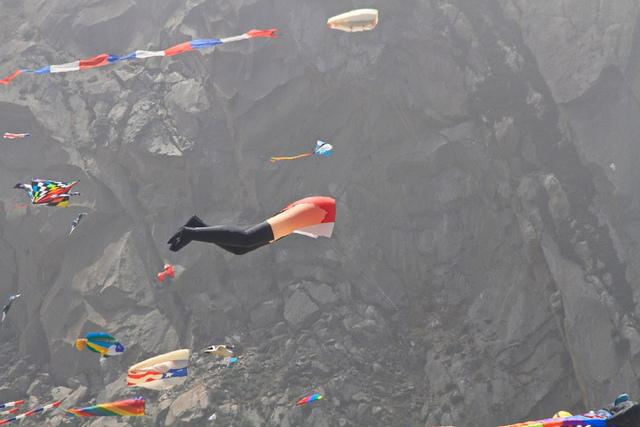What is the most popular kite shape? Please explain your reasoning. diamond/delta/box. The most popular is the diamond shaped kite. 